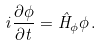<formula> <loc_0><loc_0><loc_500><loc_500>i \frac { \partial \phi } { \partial t } = \hat { H } _ { \phi } \phi \, .</formula> 